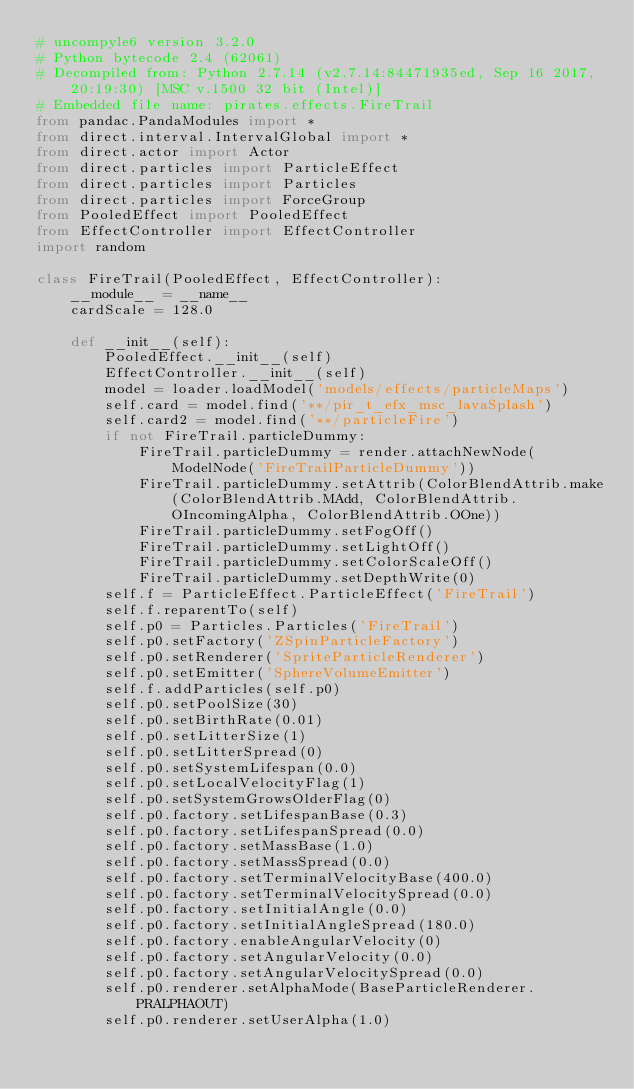Convert code to text. <code><loc_0><loc_0><loc_500><loc_500><_Python_># uncompyle6 version 3.2.0
# Python bytecode 2.4 (62061)
# Decompiled from: Python 2.7.14 (v2.7.14:84471935ed, Sep 16 2017, 20:19:30) [MSC v.1500 32 bit (Intel)]
# Embedded file name: pirates.effects.FireTrail
from pandac.PandaModules import *
from direct.interval.IntervalGlobal import *
from direct.actor import Actor
from direct.particles import ParticleEffect
from direct.particles import Particles
from direct.particles import ForceGroup
from PooledEffect import PooledEffect
from EffectController import EffectController
import random

class FireTrail(PooledEffect, EffectController):
    __module__ = __name__
    cardScale = 128.0

    def __init__(self):
        PooledEffect.__init__(self)
        EffectController.__init__(self)
        model = loader.loadModel('models/effects/particleMaps')
        self.card = model.find('**/pir_t_efx_msc_lavaSplash')
        self.card2 = model.find('**/particleFire')
        if not FireTrail.particleDummy:
            FireTrail.particleDummy = render.attachNewNode(ModelNode('FireTrailParticleDummy'))
            FireTrail.particleDummy.setAttrib(ColorBlendAttrib.make(ColorBlendAttrib.MAdd, ColorBlendAttrib.OIncomingAlpha, ColorBlendAttrib.OOne))
            FireTrail.particleDummy.setFogOff()
            FireTrail.particleDummy.setLightOff()
            FireTrail.particleDummy.setColorScaleOff()
            FireTrail.particleDummy.setDepthWrite(0)
        self.f = ParticleEffect.ParticleEffect('FireTrail')
        self.f.reparentTo(self)
        self.p0 = Particles.Particles('FireTrail')
        self.p0.setFactory('ZSpinParticleFactory')
        self.p0.setRenderer('SpriteParticleRenderer')
        self.p0.setEmitter('SphereVolumeEmitter')
        self.f.addParticles(self.p0)
        self.p0.setPoolSize(30)
        self.p0.setBirthRate(0.01)
        self.p0.setLitterSize(1)
        self.p0.setLitterSpread(0)
        self.p0.setSystemLifespan(0.0)
        self.p0.setLocalVelocityFlag(1)
        self.p0.setSystemGrowsOlderFlag(0)
        self.p0.factory.setLifespanBase(0.3)
        self.p0.factory.setLifespanSpread(0.0)
        self.p0.factory.setMassBase(1.0)
        self.p0.factory.setMassSpread(0.0)
        self.p0.factory.setTerminalVelocityBase(400.0)
        self.p0.factory.setTerminalVelocitySpread(0.0)
        self.p0.factory.setInitialAngle(0.0)
        self.p0.factory.setInitialAngleSpread(180.0)
        self.p0.factory.enableAngularVelocity(0)
        self.p0.factory.setAngularVelocity(0.0)
        self.p0.factory.setAngularVelocitySpread(0.0)
        self.p0.renderer.setAlphaMode(BaseParticleRenderer.PRALPHAOUT)
        self.p0.renderer.setUserAlpha(1.0)</code> 